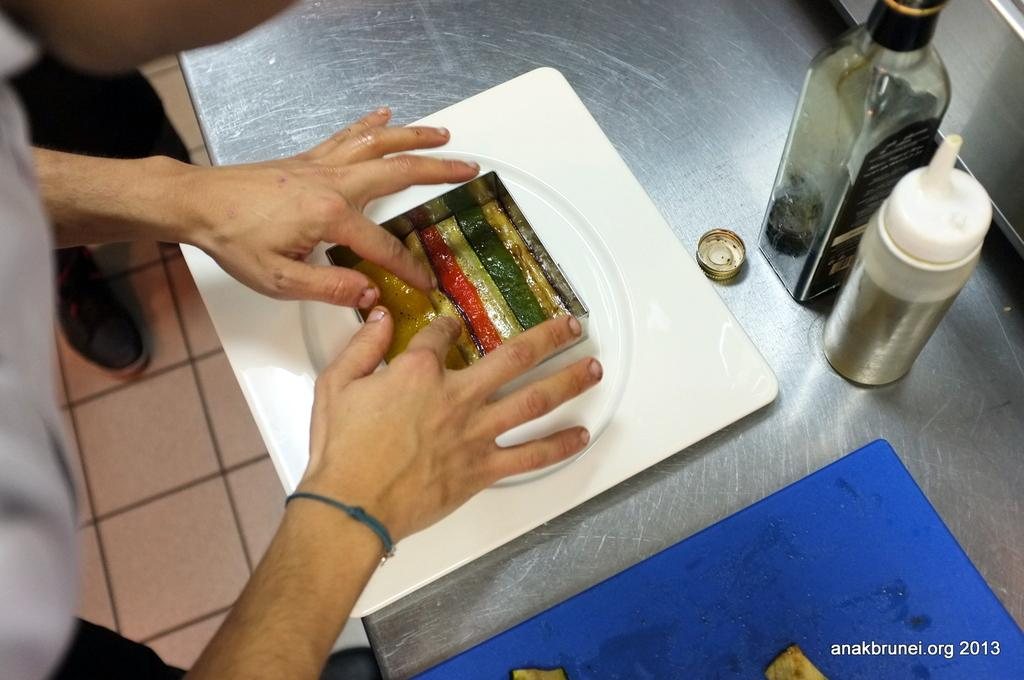Who is the person in the image? There is a man in the image. What is the man doing in the image? The man is making food in a plate. How is the man preparing the food? The man is using his hands to make the food. What type of copper material is being used by the man to make the food in the image? There is no mention of copper or any specific material being used by the man to make the food in the image. 